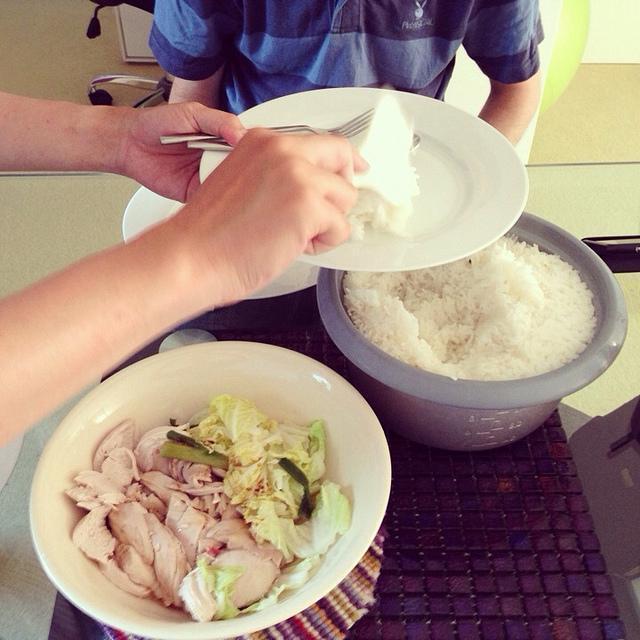How many people can be seen?
Give a very brief answer. 2. How many bowls are visible?
Give a very brief answer. 2. How many dining tables are visible?
Give a very brief answer. 1. 